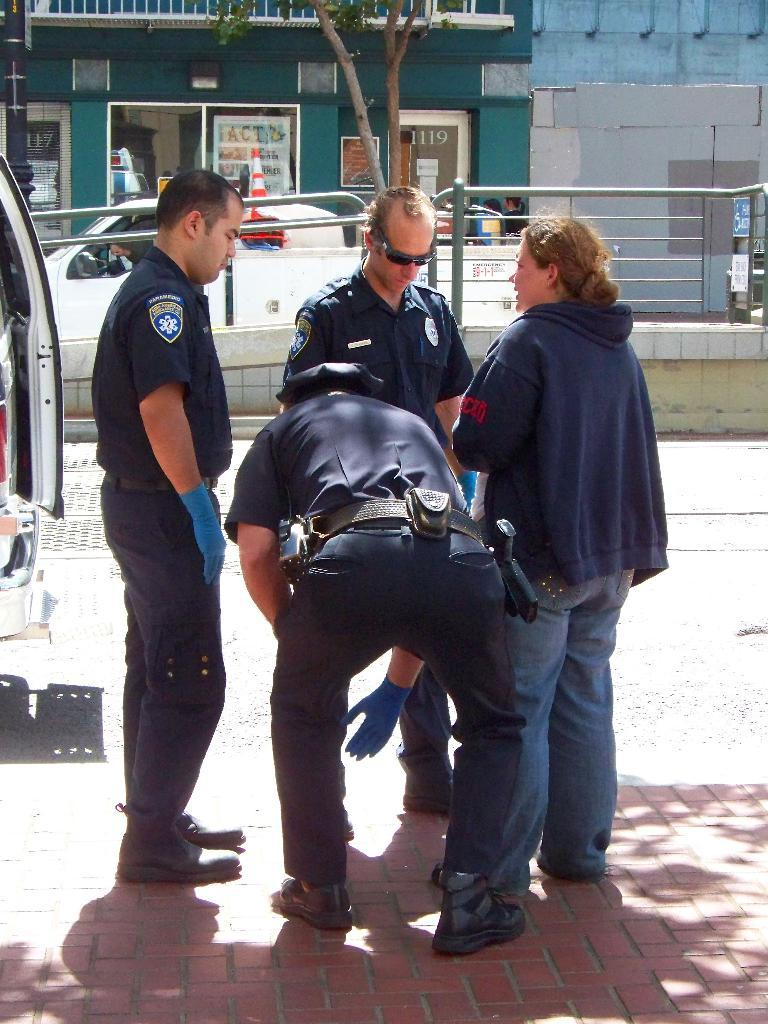How many people are present in the image? There are four persons standing in the image. What can be seen in the background of the image? There are buildings, a tree, a vehicle, and iron grilles in the background of the image. What type of fowl can be seen on the committee at the seashore in the image? There is no committee, seashore, or fowl present in the image. 